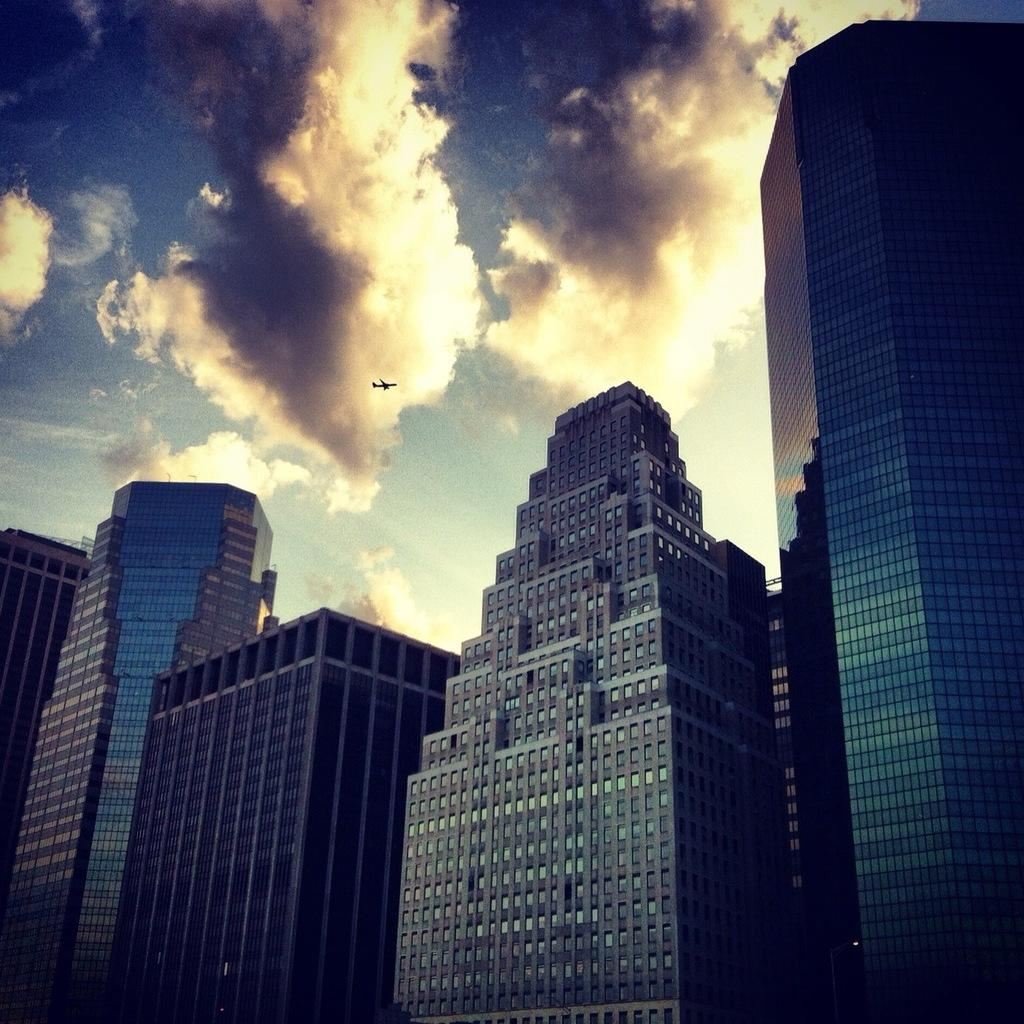What type of structures can be seen in the image? There are buildings in the image. How would you describe the sky in the image? The sky is cloudy in the image. Can you identify any vehicles in the image? Yes, there is a plane in the air in the image. What type of chain is being used to hold the protest in the image? There is no protest or chain present in the image. What type of magic is being performed by the buildings in the image? There is no magic or indication of any magical activity in the image. 